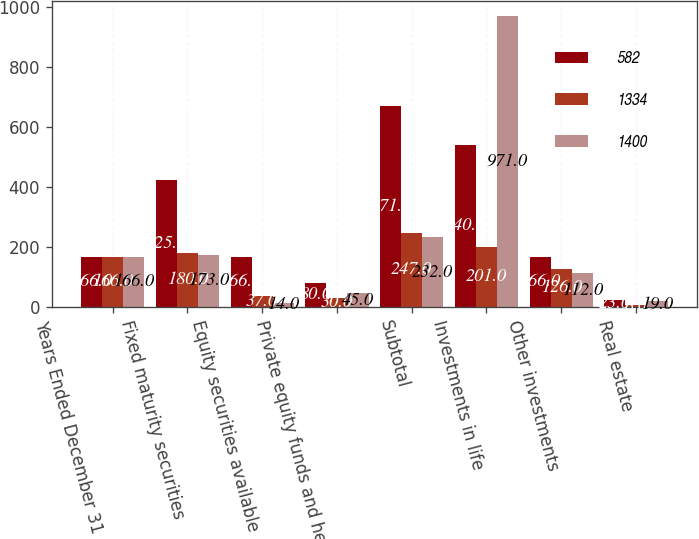Convert chart. <chart><loc_0><loc_0><loc_500><loc_500><stacked_bar_chart><ecel><fcel>Years Ended December 31 (in<fcel>Fixed maturity securities<fcel>Equity securities available<fcel>Private equity funds and hedge<fcel>Subtotal<fcel>Investments in life<fcel>Other investments<fcel>Real estate<nl><fcel>582<fcel>166<fcel>425<fcel>166<fcel>80<fcel>671<fcel>540<fcel>166<fcel>23<nl><fcel>1334<fcel>166<fcel>180<fcel>37<fcel>30<fcel>247<fcel>201<fcel>126<fcel>8<nl><fcel>1400<fcel>166<fcel>173<fcel>14<fcel>45<fcel>232<fcel>971<fcel>112<fcel>19<nl></chart> 